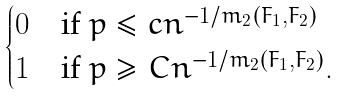Convert formula to latex. <formula><loc_0><loc_0><loc_500><loc_500>\begin{cases} 0 & \text {if $p\leq c n^{-1/m_{2}(F_{1},F_{2})}$} \\ 1 & \text {if $p\geq C n^{-1/m_{2}(F_{1},F_{2})}$} . \end{cases}</formula> 